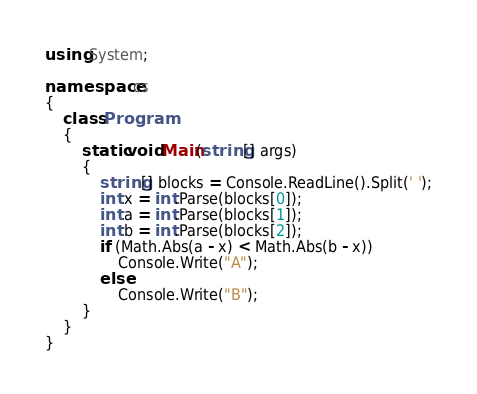Convert code to text. <code><loc_0><loc_0><loc_500><loc_500><_C#_>using System;

namespace cs
{
    class Program
    {
        static void Main(string[] args)
        {
            string[] blocks = Console.ReadLine().Split(' ');
            int x = int.Parse(blocks[0]);
            int a = int.Parse(blocks[1]);
            int b = int.Parse(blocks[2]);
            if (Math.Abs(a - x) < Math.Abs(b - x))
                Console.Write("A");
            else
                Console.Write("B");
        }
    }
}</code> 